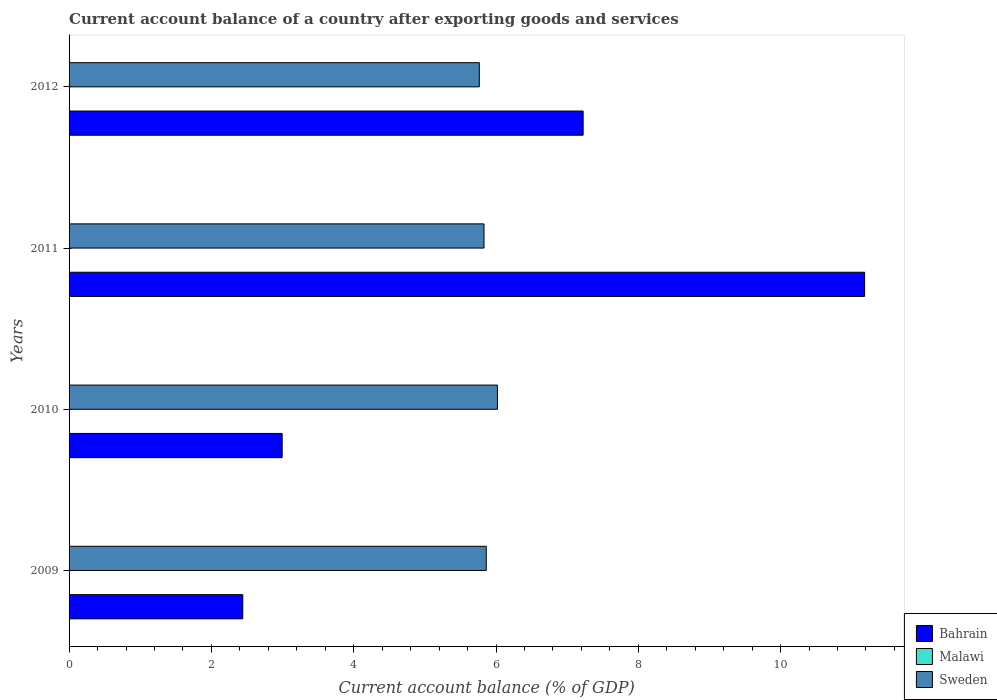How many groups of bars are there?
Your response must be concise. 4. Are the number of bars per tick equal to the number of legend labels?
Your response must be concise. No. How many bars are there on the 1st tick from the top?
Your answer should be compact. 2. What is the account balance in Sweden in 2012?
Give a very brief answer. 5.77. Across all years, what is the maximum account balance in Sweden?
Make the answer very short. 6.02. What is the total account balance in Sweden in the graph?
Make the answer very short. 23.48. What is the difference between the account balance in Bahrain in 2011 and that in 2012?
Give a very brief answer. 3.96. What is the difference between the account balance in Malawi in 2009 and the account balance in Bahrain in 2011?
Offer a terse response. -11.18. In the year 2009, what is the difference between the account balance in Bahrain and account balance in Sweden?
Keep it short and to the point. -3.42. In how many years, is the account balance in Malawi greater than 2.4 %?
Give a very brief answer. 0. What is the ratio of the account balance in Sweden in 2009 to that in 2010?
Offer a very short reply. 0.97. Is the difference between the account balance in Bahrain in 2009 and 2010 greater than the difference between the account balance in Sweden in 2009 and 2010?
Offer a very short reply. No. What is the difference between the highest and the second highest account balance in Sweden?
Make the answer very short. 0.16. What is the difference between the highest and the lowest account balance in Sweden?
Give a very brief answer. 0.25. In how many years, is the account balance in Bahrain greater than the average account balance in Bahrain taken over all years?
Your answer should be very brief. 2. Are all the bars in the graph horizontal?
Offer a very short reply. Yes. What is the difference between two consecutive major ticks on the X-axis?
Keep it short and to the point. 2. Does the graph contain grids?
Provide a succinct answer. No. Where does the legend appear in the graph?
Provide a short and direct response. Bottom right. How many legend labels are there?
Give a very brief answer. 3. How are the legend labels stacked?
Make the answer very short. Vertical. What is the title of the graph?
Give a very brief answer. Current account balance of a country after exporting goods and services. Does "Sweden" appear as one of the legend labels in the graph?
Your response must be concise. Yes. What is the label or title of the X-axis?
Your answer should be compact. Current account balance (% of GDP). What is the Current account balance (% of GDP) of Bahrain in 2009?
Offer a terse response. 2.44. What is the Current account balance (% of GDP) in Malawi in 2009?
Your answer should be very brief. 0. What is the Current account balance (% of GDP) in Sweden in 2009?
Give a very brief answer. 5.86. What is the Current account balance (% of GDP) of Bahrain in 2010?
Your response must be concise. 2.99. What is the Current account balance (% of GDP) in Malawi in 2010?
Ensure brevity in your answer.  0. What is the Current account balance (% of GDP) of Sweden in 2010?
Provide a short and direct response. 6.02. What is the Current account balance (% of GDP) of Bahrain in 2011?
Provide a short and direct response. 11.18. What is the Current account balance (% of GDP) in Sweden in 2011?
Keep it short and to the point. 5.83. What is the Current account balance (% of GDP) in Bahrain in 2012?
Provide a succinct answer. 7.22. What is the Current account balance (% of GDP) of Malawi in 2012?
Your answer should be compact. 0. What is the Current account balance (% of GDP) in Sweden in 2012?
Give a very brief answer. 5.77. Across all years, what is the maximum Current account balance (% of GDP) in Bahrain?
Offer a terse response. 11.18. Across all years, what is the maximum Current account balance (% of GDP) of Sweden?
Offer a terse response. 6.02. Across all years, what is the minimum Current account balance (% of GDP) of Bahrain?
Offer a terse response. 2.44. Across all years, what is the minimum Current account balance (% of GDP) of Sweden?
Give a very brief answer. 5.77. What is the total Current account balance (% of GDP) in Bahrain in the graph?
Provide a succinct answer. 23.84. What is the total Current account balance (% of GDP) of Sweden in the graph?
Your response must be concise. 23.48. What is the difference between the Current account balance (% of GDP) in Bahrain in 2009 and that in 2010?
Offer a terse response. -0.55. What is the difference between the Current account balance (% of GDP) in Sweden in 2009 and that in 2010?
Your answer should be very brief. -0.16. What is the difference between the Current account balance (% of GDP) of Bahrain in 2009 and that in 2011?
Your response must be concise. -8.74. What is the difference between the Current account balance (% of GDP) of Sweden in 2009 and that in 2011?
Provide a succinct answer. 0.03. What is the difference between the Current account balance (% of GDP) in Bahrain in 2009 and that in 2012?
Offer a terse response. -4.78. What is the difference between the Current account balance (% of GDP) of Sweden in 2009 and that in 2012?
Provide a succinct answer. 0.1. What is the difference between the Current account balance (% of GDP) of Bahrain in 2010 and that in 2011?
Ensure brevity in your answer.  -8.19. What is the difference between the Current account balance (% of GDP) in Sweden in 2010 and that in 2011?
Keep it short and to the point. 0.19. What is the difference between the Current account balance (% of GDP) in Bahrain in 2010 and that in 2012?
Offer a very short reply. -4.23. What is the difference between the Current account balance (% of GDP) of Sweden in 2010 and that in 2012?
Your answer should be compact. 0.25. What is the difference between the Current account balance (% of GDP) in Bahrain in 2011 and that in 2012?
Make the answer very short. 3.96. What is the difference between the Current account balance (% of GDP) of Sweden in 2011 and that in 2012?
Your answer should be compact. 0.07. What is the difference between the Current account balance (% of GDP) in Bahrain in 2009 and the Current account balance (% of GDP) in Sweden in 2010?
Provide a succinct answer. -3.58. What is the difference between the Current account balance (% of GDP) of Bahrain in 2009 and the Current account balance (% of GDP) of Sweden in 2011?
Your answer should be compact. -3.39. What is the difference between the Current account balance (% of GDP) in Bahrain in 2009 and the Current account balance (% of GDP) in Sweden in 2012?
Provide a short and direct response. -3.32. What is the difference between the Current account balance (% of GDP) of Bahrain in 2010 and the Current account balance (% of GDP) of Sweden in 2011?
Keep it short and to the point. -2.84. What is the difference between the Current account balance (% of GDP) in Bahrain in 2010 and the Current account balance (% of GDP) in Sweden in 2012?
Provide a succinct answer. -2.77. What is the difference between the Current account balance (% of GDP) of Bahrain in 2011 and the Current account balance (% of GDP) of Sweden in 2012?
Make the answer very short. 5.42. What is the average Current account balance (% of GDP) of Bahrain per year?
Offer a terse response. 5.96. What is the average Current account balance (% of GDP) of Sweden per year?
Offer a terse response. 5.87. In the year 2009, what is the difference between the Current account balance (% of GDP) of Bahrain and Current account balance (% of GDP) of Sweden?
Offer a terse response. -3.42. In the year 2010, what is the difference between the Current account balance (% of GDP) in Bahrain and Current account balance (% of GDP) in Sweden?
Provide a short and direct response. -3.03. In the year 2011, what is the difference between the Current account balance (% of GDP) of Bahrain and Current account balance (% of GDP) of Sweden?
Offer a very short reply. 5.35. In the year 2012, what is the difference between the Current account balance (% of GDP) of Bahrain and Current account balance (% of GDP) of Sweden?
Offer a terse response. 1.46. What is the ratio of the Current account balance (% of GDP) of Bahrain in 2009 to that in 2010?
Ensure brevity in your answer.  0.82. What is the ratio of the Current account balance (% of GDP) of Sweden in 2009 to that in 2010?
Keep it short and to the point. 0.97. What is the ratio of the Current account balance (% of GDP) in Bahrain in 2009 to that in 2011?
Your answer should be very brief. 0.22. What is the ratio of the Current account balance (% of GDP) of Sweden in 2009 to that in 2011?
Offer a terse response. 1.01. What is the ratio of the Current account balance (% of GDP) in Bahrain in 2009 to that in 2012?
Offer a very short reply. 0.34. What is the ratio of the Current account balance (% of GDP) in Sweden in 2009 to that in 2012?
Provide a short and direct response. 1.02. What is the ratio of the Current account balance (% of GDP) in Bahrain in 2010 to that in 2011?
Provide a succinct answer. 0.27. What is the ratio of the Current account balance (% of GDP) in Sweden in 2010 to that in 2011?
Your answer should be compact. 1.03. What is the ratio of the Current account balance (% of GDP) of Bahrain in 2010 to that in 2012?
Ensure brevity in your answer.  0.41. What is the ratio of the Current account balance (% of GDP) in Sweden in 2010 to that in 2012?
Keep it short and to the point. 1.04. What is the ratio of the Current account balance (% of GDP) in Bahrain in 2011 to that in 2012?
Offer a very short reply. 1.55. What is the ratio of the Current account balance (% of GDP) of Sweden in 2011 to that in 2012?
Ensure brevity in your answer.  1.01. What is the difference between the highest and the second highest Current account balance (% of GDP) in Bahrain?
Make the answer very short. 3.96. What is the difference between the highest and the second highest Current account balance (% of GDP) of Sweden?
Provide a short and direct response. 0.16. What is the difference between the highest and the lowest Current account balance (% of GDP) of Bahrain?
Keep it short and to the point. 8.74. What is the difference between the highest and the lowest Current account balance (% of GDP) in Sweden?
Your answer should be very brief. 0.25. 